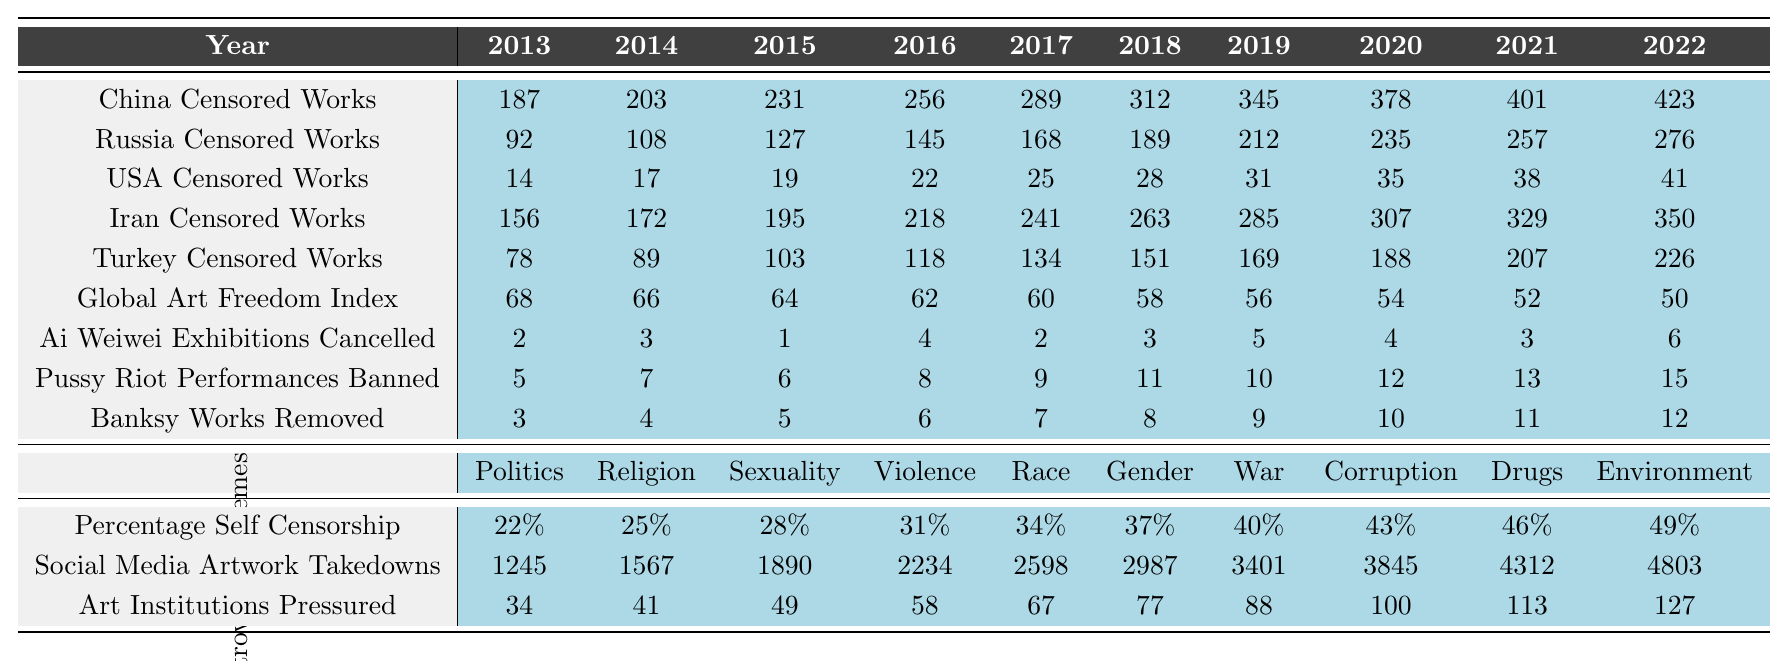What was the total number of works censored in China in 2022? In 2022, China had 423 censored works as listed in the table.
Answer: 423 How many more works were censored in Iran than in the USA in 2021? In 2021, Iran had 329 censored works, while the USA had 38. The difference is 329 - 38 = 291.
Answer: 291 What is the trend observed in the Global Art Freedom Index from 2013 to 2022? The Global Art Freedom Index decreased from 68 in 2013 to 50 in 2022, indicating a downward trend in art freedom over the decade.
Answer: Downward trend In which year were the most Ai Weiwei exhibitions canceled? The most Ai Weiwei exhibitions were canceled in 2022, with a total of 6 exhibitions according to the table.
Answer: 2022 What was the percentage increase in self-censorship from 2013 to 2022? The percentage of self-censorship increased from 22% in 2013 to 49% in 2022. The increase is calculated as 49 - 22 = 27 percentage points.
Answer: 27 percentage points In what year did Banksy have the least amount of work removed? Banksy had the least amount of work removed in 2013, with only 3 works removed according to the table.
Answer: 2013 What is the average number of works censored in Russia over the last decade? To find the average, sum the censored works from 2013-2022 (92 + 108 + 127 + 145 + 168 + 189 + 212 + 235 + 257 + 276 = 1,728) and divide by the number of years (10). The average is 1,728 / 10 = 172.8.
Answer: 172.8 How many social media artwork takedowns were reported in 2015? In 2015, there were 1,890 social media artwork takedowns reported as per the table.
Answer: 1,890 What was the cumulative total of art institutions pressured from 2013 to 2022? The cumulative total is calculated by summing the numbers from each year: (34 + 41 + 49 + 58 + 67 + 77 + 88 + 100 + 113 + 127 = 811).
Answer: 811 Did the number of Pussy Riot performances banned exceed 10 in any year? Yes, Pussy Riot performances banned exceeded 10 in 2018 (11), 2019 (10), 2020 (12), 2021 (13), and 2022 (15).
Answer: Yes What was the percentage of self-censorship in the year with the highest number of censored works in the USA? The highest number of censored works in the USA was in 2022 with 41 works, and the self-censorship at that time was 49%.
Answer: 49% 